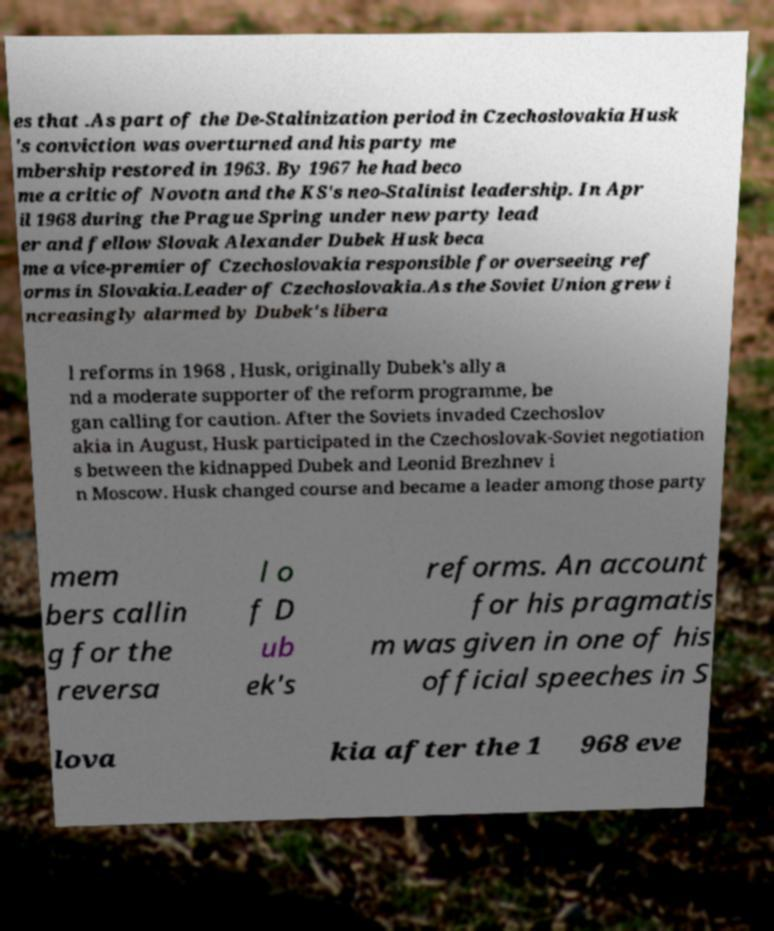Please read and relay the text visible in this image. What does it say? es that .As part of the De-Stalinization period in Czechoslovakia Husk 's conviction was overturned and his party me mbership restored in 1963. By 1967 he had beco me a critic of Novotn and the KS's neo-Stalinist leadership. In Apr il 1968 during the Prague Spring under new party lead er and fellow Slovak Alexander Dubek Husk beca me a vice-premier of Czechoslovakia responsible for overseeing ref orms in Slovakia.Leader of Czechoslovakia.As the Soviet Union grew i ncreasingly alarmed by Dubek's libera l reforms in 1968 , Husk, originally Dubek's ally a nd a moderate supporter of the reform programme, be gan calling for caution. After the Soviets invaded Czechoslov akia in August, Husk participated in the Czechoslovak-Soviet negotiation s between the kidnapped Dubek and Leonid Brezhnev i n Moscow. Husk changed course and became a leader among those party mem bers callin g for the reversa l o f D ub ek's reforms. An account for his pragmatis m was given in one of his official speeches in S lova kia after the 1 968 eve 